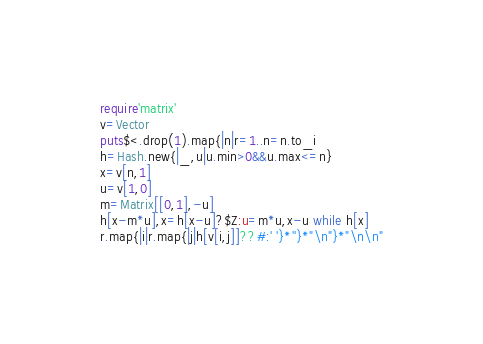Convert code to text. <code><loc_0><loc_0><loc_500><loc_500><_Ruby_>require'matrix'
v=Vector
puts$<.drop(1).map{|n|r=1..n=n.to_i
h=Hash.new{|_,u|u.min>0&&u.max<=n}
x=v[n,1]
u=v[1,0]
m=Matrix[[0,1],-u]
h[x-m*u],x=h[x-u]?$Z:u=m*u,x-u while h[x]
r.map{|i|r.map{|j|h[v[i,j]]??#:' '}*''}*"\n"}*"\n\n"

</code> 